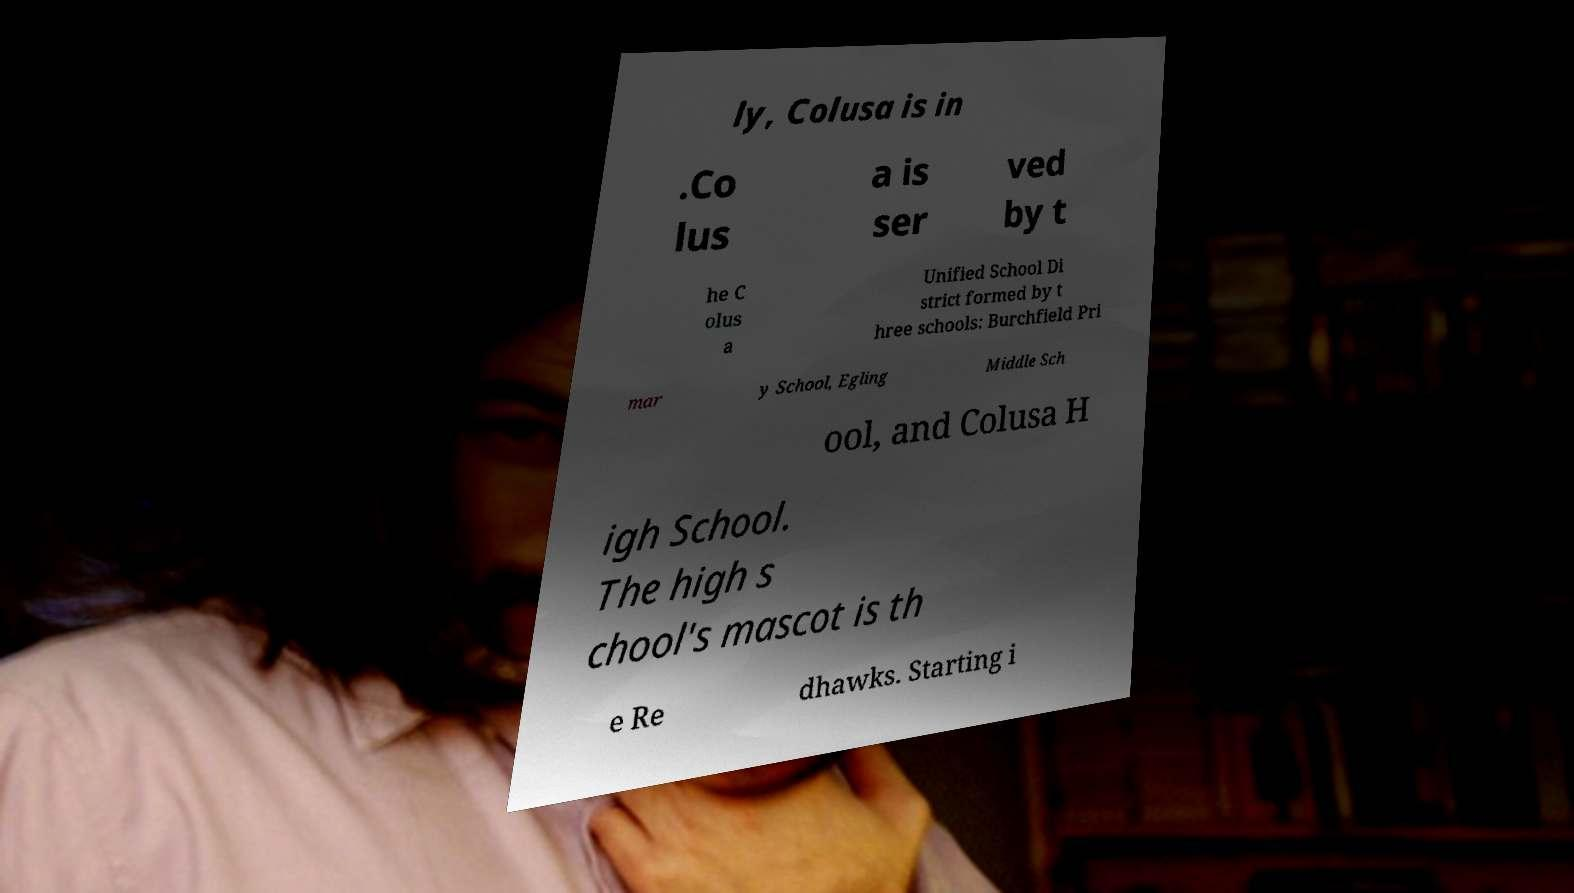What messages or text are displayed in this image? I need them in a readable, typed format. ly, Colusa is in .Co lus a is ser ved by t he C olus a Unified School Di strict formed by t hree schools: Burchfield Pri mar y School, Egling Middle Sch ool, and Colusa H igh School. The high s chool's mascot is th e Re dhawks. Starting i 